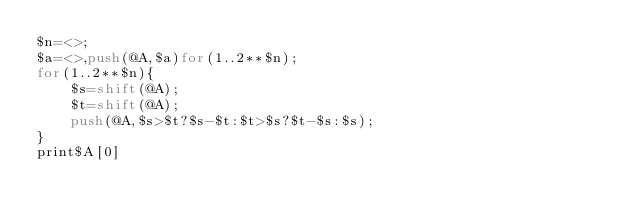<code> <loc_0><loc_0><loc_500><loc_500><_Perl_>$n=<>;
$a=<>,push(@A,$a)for(1..2**$n);
for(1..2**$n){
    $s=shift(@A);
    $t=shift(@A);
    push(@A,$s>$t?$s-$t:$t>$s?$t-$s:$s);
}
print$A[0]</code> 